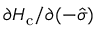<formula> <loc_0><loc_0><loc_500><loc_500>{ \partial H _ { c } } / { \partial ( - \hat { \sigma } ) }</formula> 